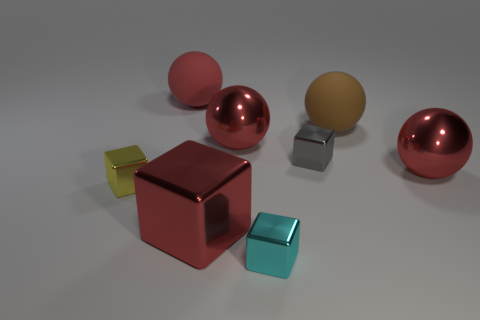There is a matte sphere that is behind the brown rubber object; how many brown things are on the left side of it?
Your answer should be compact. 0. Are there any other big metallic objects of the same shape as the gray shiny thing?
Make the answer very short. Yes. Does the small yellow object in front of the brown sphere have the same shape as the large rubber thing to the left of the tiny cyan metallic cube?
Offer a very short reply. No. There is a red metallic object that is behind the red shiny cube and to the left of the large brown rubber sphere; what shape is it?
Provide a short and direct response. Sphere. Is there a metal sphere of the same size as the cyan object?
Provide a succinct answer. No. There is a large metallic cube; is it the same color as the big metallic ball that is to the left of the tiny cyan cube?
Make the answer very short. Yes. What is the large block made of?
Provide a succinct answer. Metal. There is a metallic thing to the right of the brown ball; what color is it?
Give a very brief answer. Red. What number of matte things have the same color as the large block?
Make the answer very short. 1. How many red balls are in front of the big red matte ball and behind the gray thing?
Offer a very short reply. 1. 